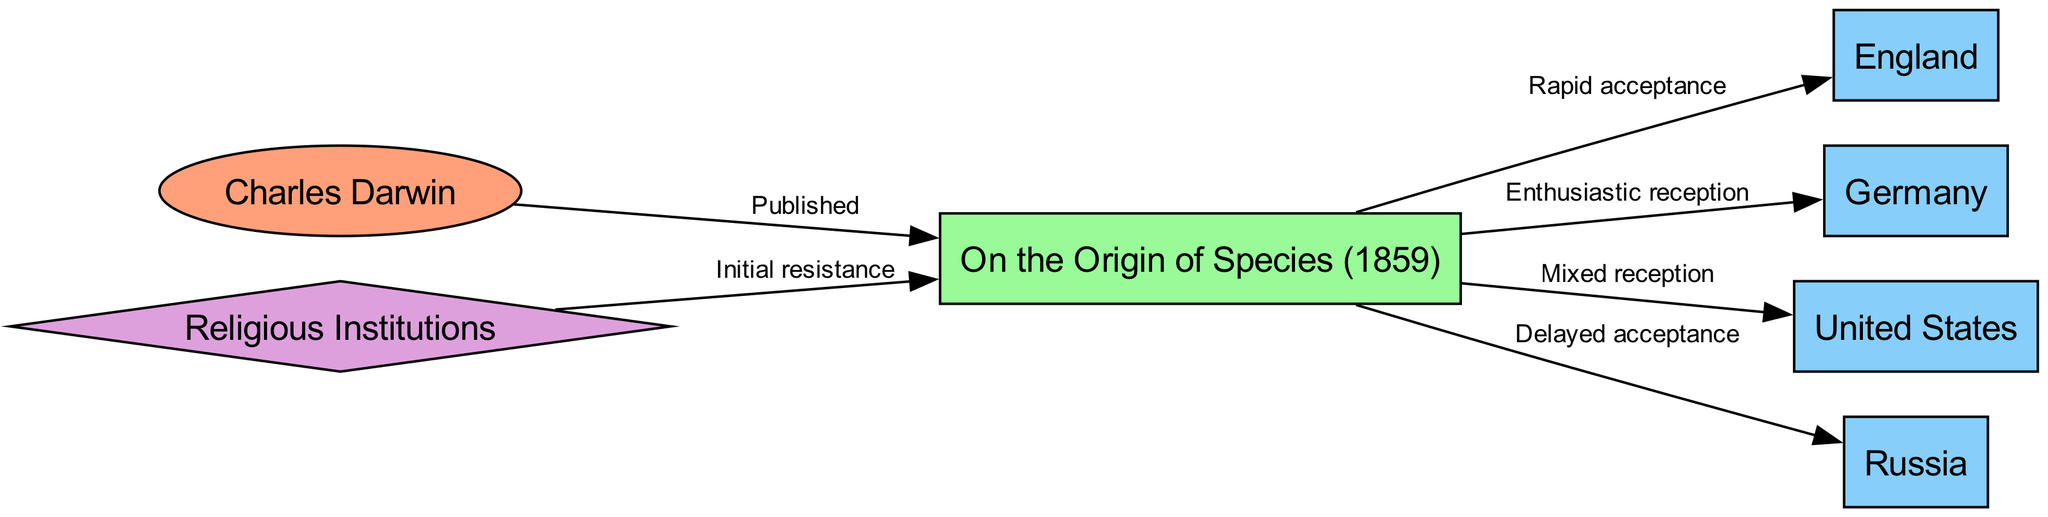What is the title of the publication associated with Charles Darwin? The diagram indicates that the publication associated with Charles Darwin is "On the Origin of Species (1859)," as this node directly connects to Darwin and represents his groundbreaking work.
Answer: On the Origin of Species (1859) Which country showed rapid acceptance of Darwin's theory? The diagram shows a direct edge from "On the Origin of Species" to "England" labeled as "Rapid acceptance," indicating that England was the country where the theory was accepted quickly.
Answer: England How many countries are represented in the diagram? By counting the nodes labeled as countries, we find that there are four distinct countries represented: England, Germany, USA, and Russia.
Answer: 4 What type of organization initially resisted the acceptance of Darwin's theory? The diagram connects "Religious Institutions" to "On the Origin of Species" with an edge labeled "Initial resistance," indicating that this type of organization was resistant to Darwin's ideas.
Answer: Religious Institutions Which country had a mixed reception of the theory? Through the edges connected to "On the Origin of Species," the diagram indicates that the USA had a "Mixed reception," meaning the response to Darwin's theory was not completely accepting or rejecting.
Answer: USA What was the reaction to Darwin's theory in Russia? The diagram details a connection from "On the Origin of Species" to "Russia" marked "Delayed acceptance," indicating that the reception of Darwin's theory in Russia was slower compared to other countries.
Answer: Delayed acceptance Which country is associated with an enthusiastic reception of Darwin's work? The edge from "On the Origin of Species" to "Germany" labeled "Enthusiastic reception" suggests that Germany embraced Darwin's theory positively and eagerly.
Answer: Germany How does the diagram describe the relationship between Darwin and his publication? The direct edge from "Darwin" to "On the Origin of Species" labeled "Published" clearly describes the relationship, indicating that Darwin was the author who published this influential work.
Answer: Published 